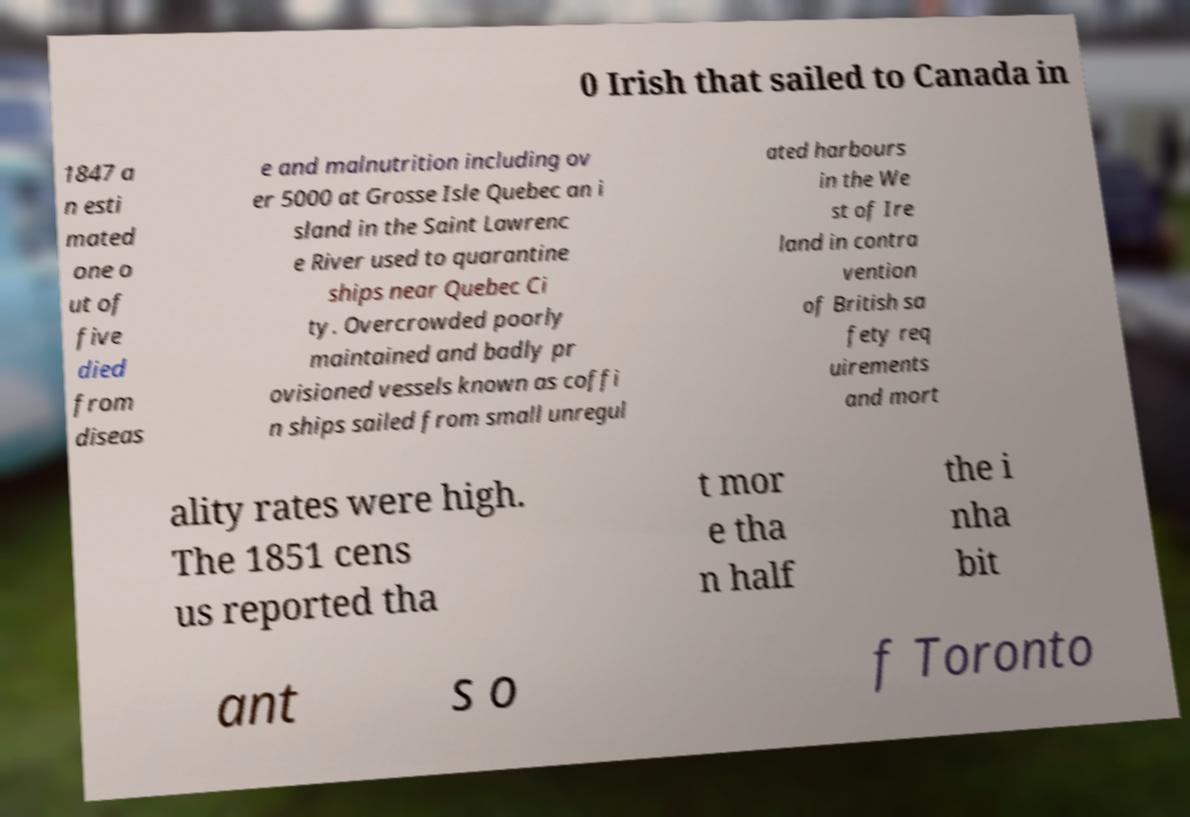Please identify and transcribe the text found in this image. 0 Irish that sailed to Canada in 1847 a n esti mated one o ut of five died from diseas e and malnutrition including ov er 5000 at Grosse Isle Quebec an i sland in the Saint Lawrenc e River used to quarantine ships near Quebec Ci ty. Overcrowded poorly maintained and badly pr ovisioned vessels known as coffi n ships sailed from small unregul ated harbours in the We st of Ire land in contra vention of British sa fety req uirements and mort ality rates were high. The 1851 cens us reported tha t mor e tha n half the i nha bit ant s o f Toronto 